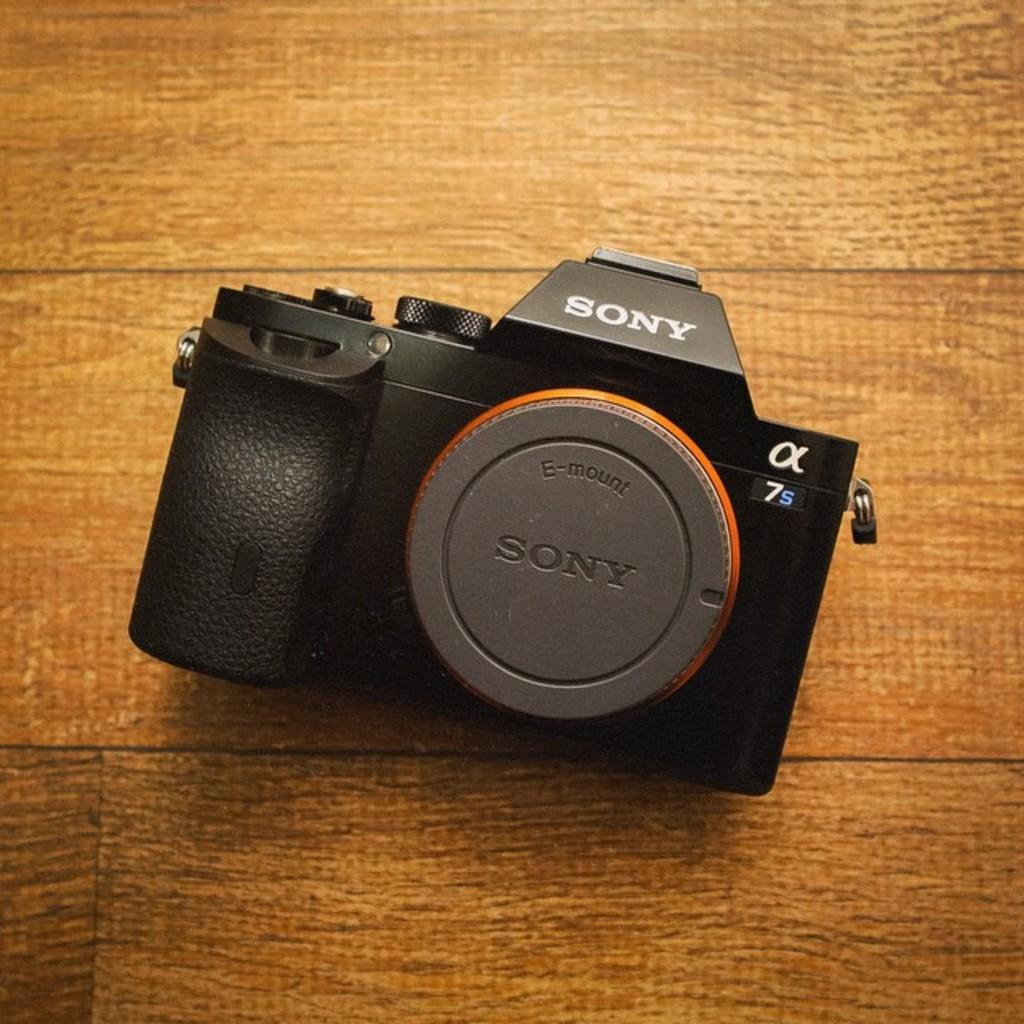<image>
Write a terse but informative summary of the picture. An antique Sony Camera, model number 7s is sitting on a wooden floor 